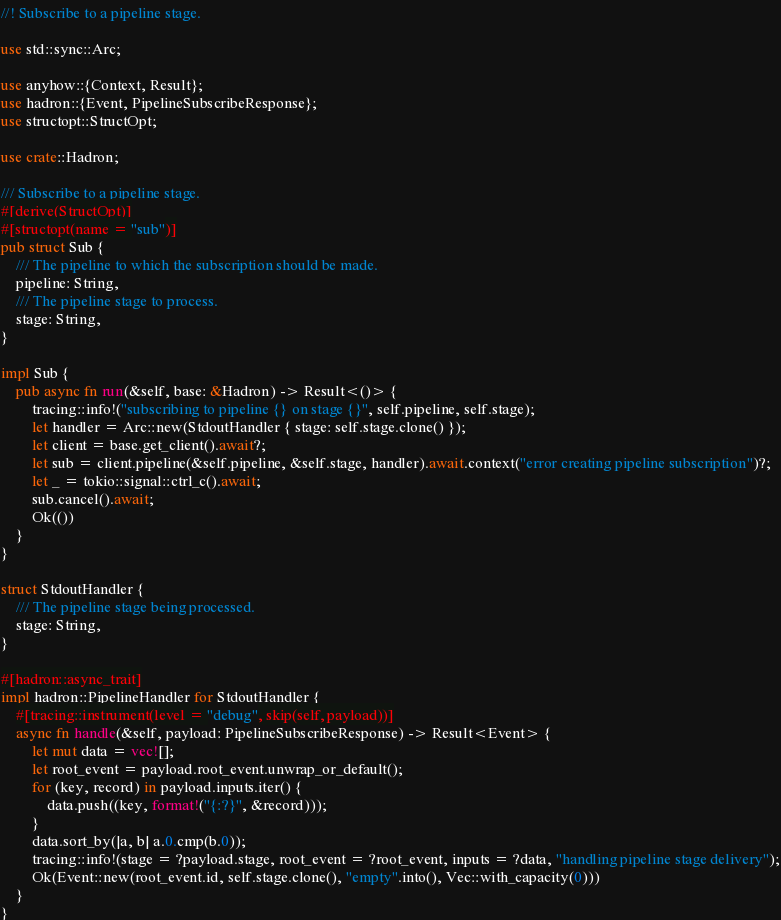<code> <loc_0><loc_0><loc_500><loc_500><_Rust_>//! Subscribe to a pipeline stage.

use std::sync::Arc;

use anyhow::{Context, Result};
use hadron::{Event, PipelineSubscribeResponse};
use structopt::StructOpt;

use crate::Hadron;

/// Subscribe to a pipeline stage.
#[derive(StructOpt)]
#[structopt(name = "sub")]
pub struct Sub {
    /// The pipeline to which the subscription should be made.
    pipeline: String,
    /// The pipeline stage to process.
    stage: String,
}

impl Sub {
    pub async fn run(&self, base: &Hadron) -> Result<()> {
        tracing::info!("subscribing to pipeline {} on stage {}", self.pipeline, self.stage);
        let handler = Arc::new(StdoutHandler { stage: self.stage.clone() });
        let client = base.get_client().await?;
        let sub = client.pipeline(&self.pipeline, &self.stage, handler).await.context("error creating pipeline subscription")?;
        let _ = tokio::signal::ctrl_c().await;
        sub.cancel().await;
        Ok(())
    }
}

struct StdoutHandler {
    /// The pipeline stage being processed.
    stage: String,
}

#[hadron::async_trait]
impl hadron::PipelineHandler for StdoutHandler {
    #[tracing::instrument(level = "debug", skip(self, payload))]
    async fn handle(&self, payload: PipelineSubscribeResponse) -> Result<Event> {
        let mut data = vec![];
        let root_event = payload.root_event.unwrap_or_default();
        for (key, record) in payload.inputs.iter() {
            data.push((key, format!("{:?}", &record)));
        }
        data.sort_by(|a, b| a.0.cmp(b.0));
        tracing::info!(stage = ?payload.stage, root_event = ?root_event, inputs = ?data, "handling pipeline stage delivery");
        Ok(Event::new(root_event.id, self.stage.clone(), "empty".into(), Vec::with_capacity(0)))
    }
}
</code> 